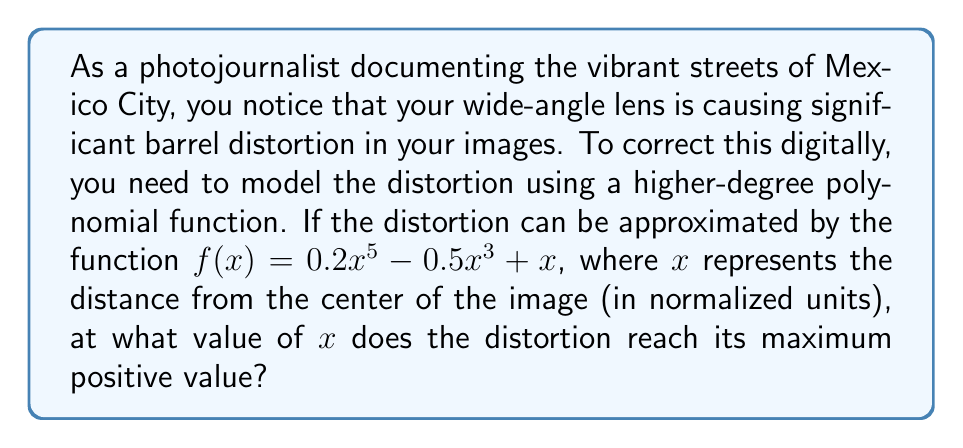Can you answer this question? To find the maximum positive value of the distortion, we need to follow these steps:

1) First, we need to find the derivative of the function $f(x)$:
   $$f'(x) = 1x^4 - 1.5x^2 + 1$$

2) To find the extrema, we set $f'(x) = 0$ and solve:
   $$1x^4 - 1.5x^2 + 1 = 0$$

3) This is a quadratic equation in $x^2$. Let $u = x^2$:
   $$u^2 - 1.5u + 1 = 0$$

4) We can solve this using the quadratic formula:
   $$u = \frac{1.5 \pm \sqrt{1.5^2 - 4(1)(1)}}{2(1)}$$
   $$u = \frac{1.5 \pm \sqrt{2.25 - 4}}{2} = \frac{1.5 \pm \sqrt{-1.75}}{2}$$

5) Since we're looking for real solutions, we discard the complex roots.

6) The other extremum occurs at $x = 0$ (when $u = 0$).

7) To determine if $x = 0$ is a maximum or minimum, we can check the second derivative:
   $$f''(x) = 4x^3 - 3x$$
   $$f''(0) = 0$$

8) Since $f''(0) = 0$, we need to check the values of $f(x)$ near $x = 0$:
   $f(-0.1) \approx -0.1$
   $f(0) = 0$
   $f(0.1) \approx 0.1$

9) This confirms that $x = 0$ is neither a maximum nor a minimum, but an inflection point.

10) Therefore, the maximum positive distortion occurs at the positive endpoint of the domain, which for a normalized image would be at $x = 1$.
Answer: The distortion reaches its maximum positive value at $x = 1$. 